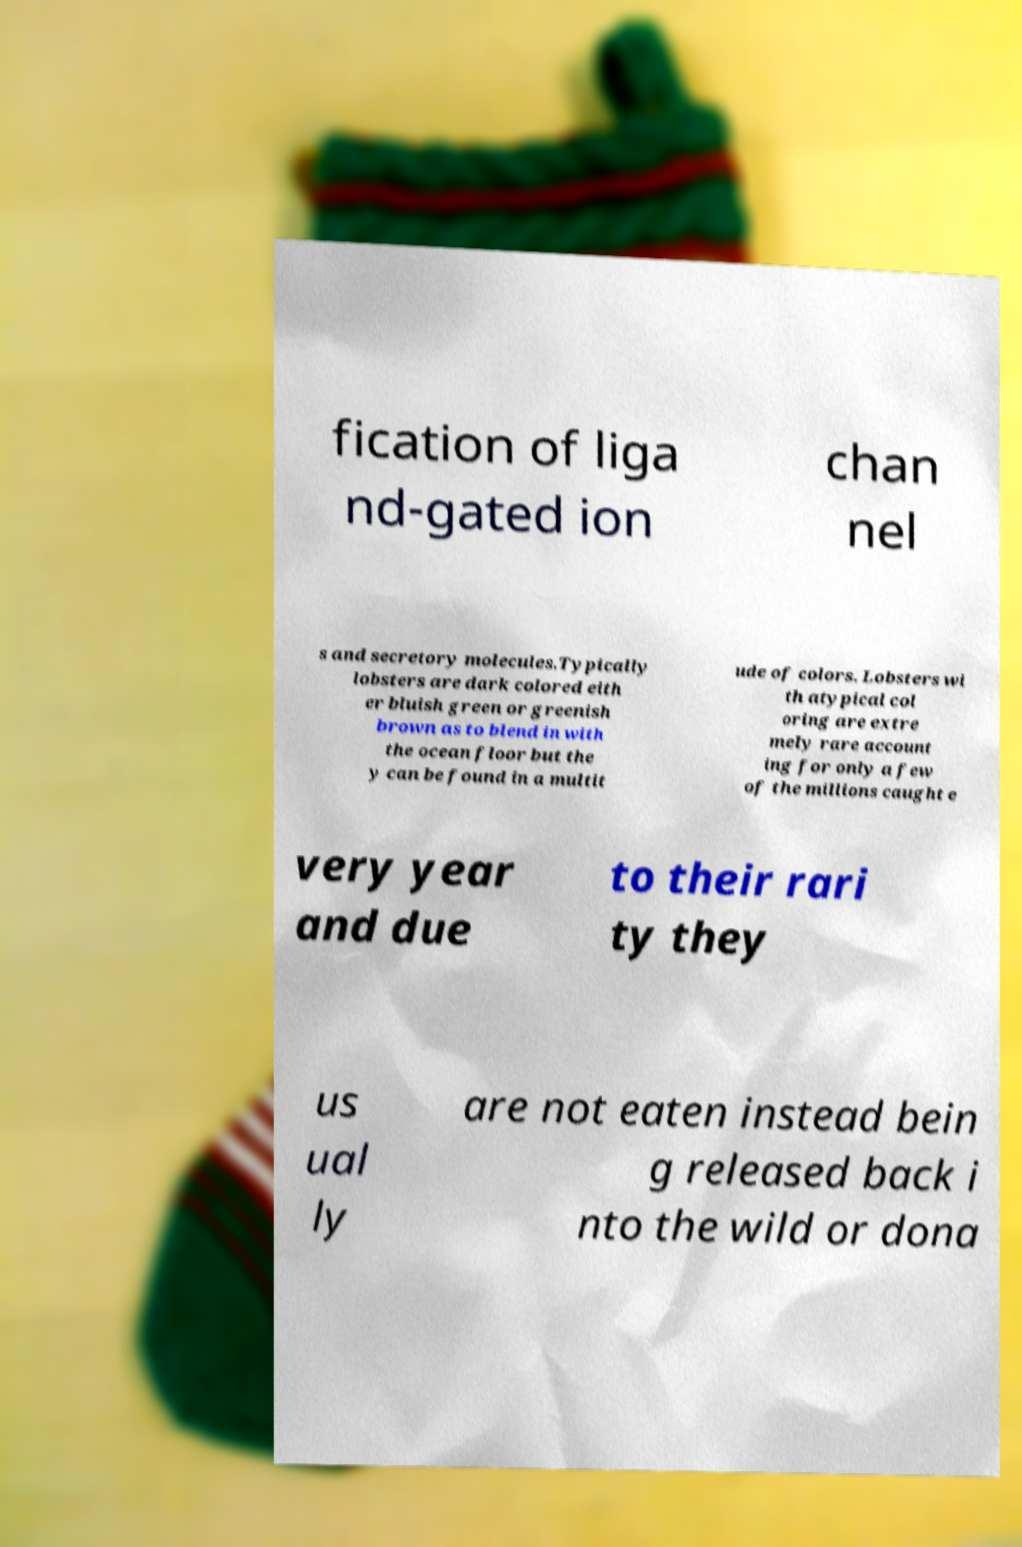I need the written content from this picture converted into text. Can you do that? fication of liga nd-gated ion chan nel s and secretory molecules.Typically lobsters are dark colored eith er bluish green or greenish brown as to blend in with the ocean floor but the y can be found in a multit ude of colors. Lobsters wi th atypical col oring are extre mely rare account ing for only a few of the millions caught e very year and due to their rari ty they us ual ly are not eaten instead bein g released back i nto the wild or dona 